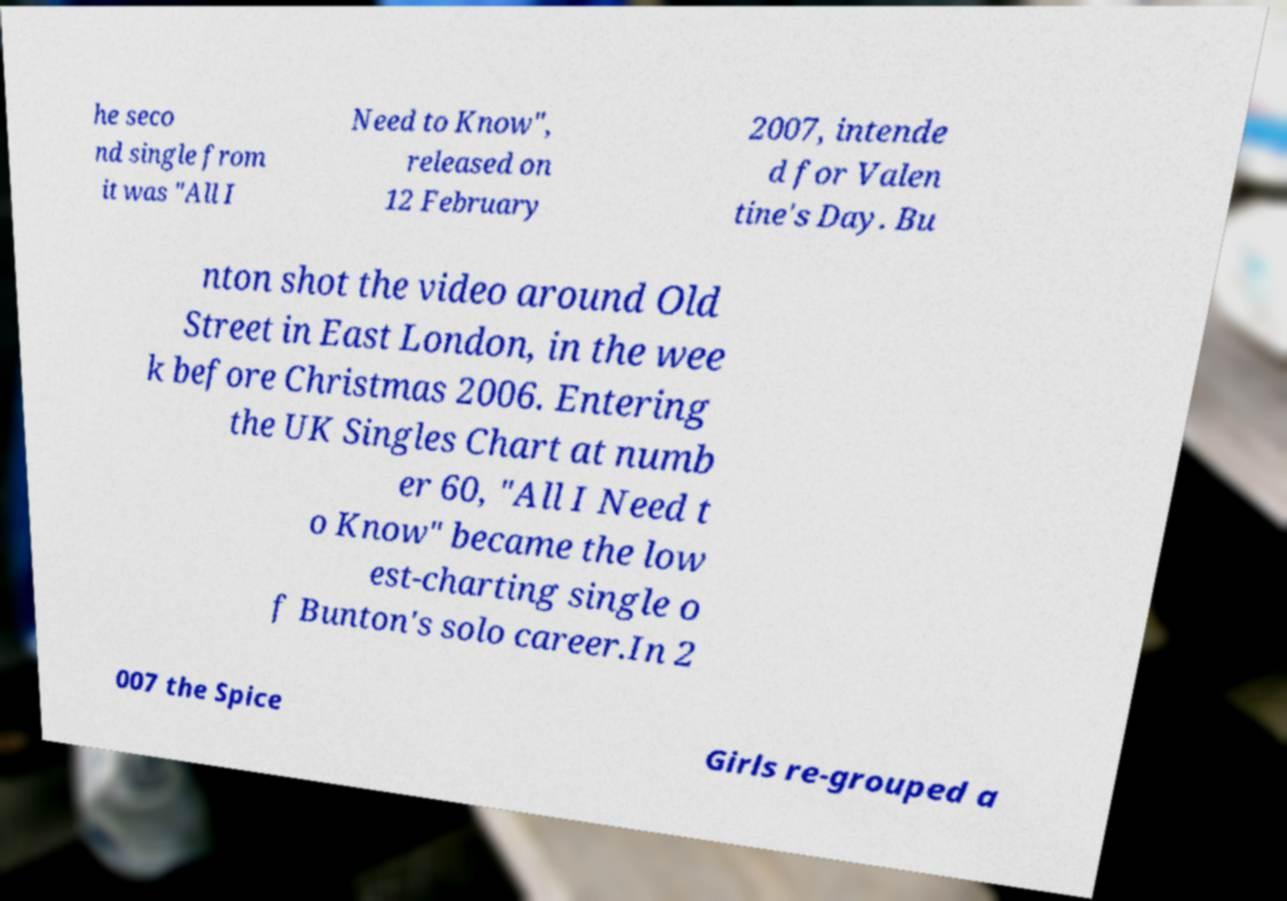Please read and relay the text visible in this image. What does it say? he seco nd single from it was "All I Need to Know", released on 12 February 2007, intende d for Valen tine's Day. Bu nton shot the video around Old Street in East London, in the wee k before Christmas 2006. Entering the UK Singles Chart at numb er 60, "All I Need t o Know" became the low est-charting single o f Bunton's solo career.In 2 007 the Spice Girls re-grouped a 